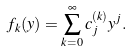<formula> <loc_0><loc_0><loc_500><loc_500>f _ { k } ( y ) = \sum _ { k = 0 } ^ { \infty } c ^ { ( k ) } _ { j } y ^ { j } .</formula> 